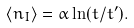Convert formula to latex. <formula><loc_0><loc_0><loc_500><loc_500>\langle n _ { I } \rangle = \alpha \ln ( t / t ^ { \prime } ) .</formula> 